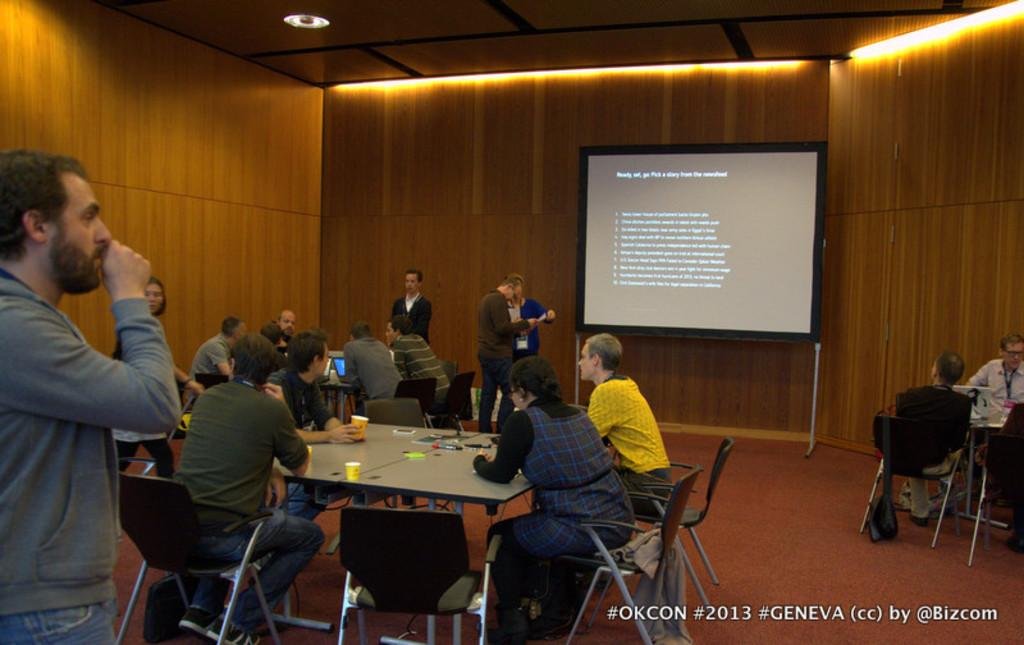How many people are in the image? There is a group of people in the image. What are some of the people doing in the image? Some people are sitting on chairs, while others are standing on the floor. What is the purpose of the projector screen in the image? The projector screen suggests that the group of people might be attending a presentation or watching a video. Can you see a squirrel climbing on the side of the projector screen in the image? There is no squirrel present in the image, nor is there any indication of a squirrel climbing on the projector screen. 